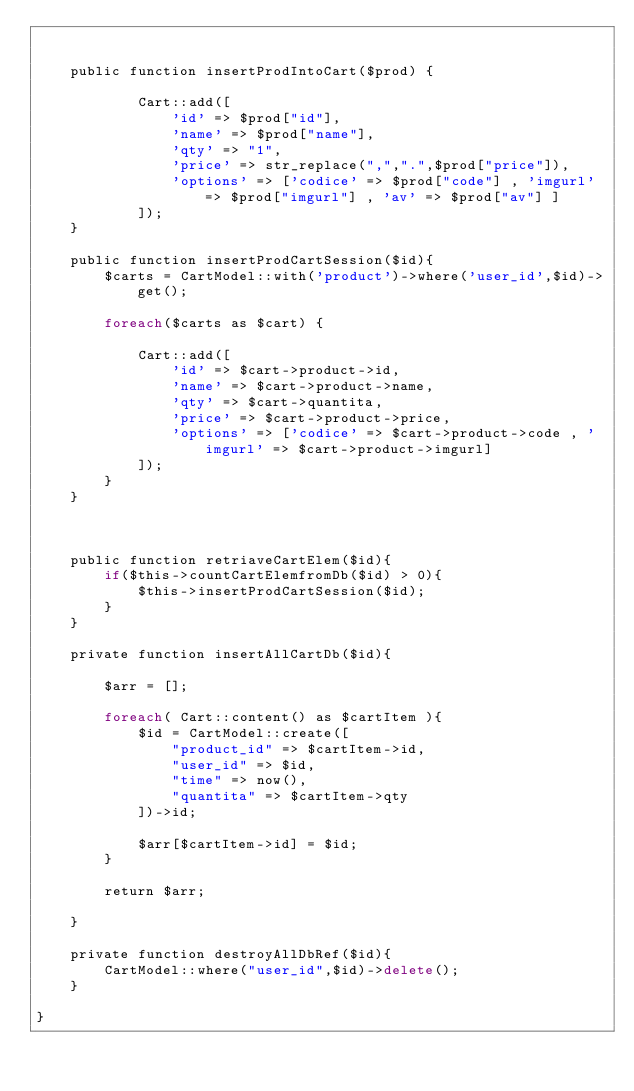Convert code to text. <code><loc_0><loc_0><loc_500><loc_500><_PHP_>

	public function insertProdIntoCart($prod) {

			Cart::add([
				'id' => $prod["id"],
				'name' => $prod["name"],
				'qty' => "1",
				'price' => str_replace(",",".",$prod["price"]),
				'options' => ['codice' => $prod["code"] , 'imgurl' => $prod["imgurl"] , 'av' => $prod["av"] ]
			]);
	}

	public function insertProdCartSession($id){
		$carts = CartModel::with('product')->where('user_id',$id)->get();

		foreach($carts as $cart) {

			Cart::add([
				'id' => $cart->product->id,
				'name' => $cart->product->name,
				'qty' => $cart->quantita,
				'price' => $cart->product->price,
				'options' => ['codice' => $cart->product->code , 'imgurl' => $cart->product->imgurl]
			]);
		}
	} 
	


	public function retriaveCartElem($id){
		if($this->countCartElemfromDb($id) > 0){
			$this->insertProdCartSession($id);
		}
	}

	private function insertAllCartDb($id){

		$arr = [];

		foreach( Cart::content() as $cartItem ){
			$id = CartModel::create([
				"product_id" => $cartItem->id,
				"user_id" => $id,
				"time" => now(),
				"quantita" => $cartItem->qty
			])->id;

			$arr[$cartItem->id] = $id;
		}

		return $arr;

	}

	private function destroyAllDbRef($id){
		CartModel::where("user_id",$id)->delete();
	}

}</code> 